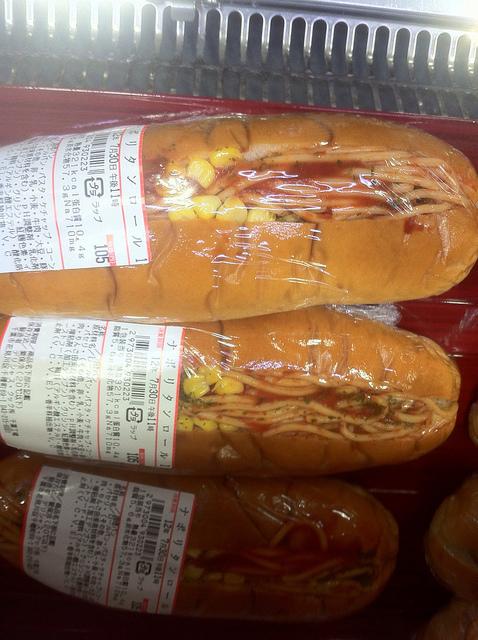Is this food ready to eat?
Keep it brief. Yes. Are these prepared ahead of time?
Keep it brief. Yes. What language is that?
Short answer required. Chinese. 